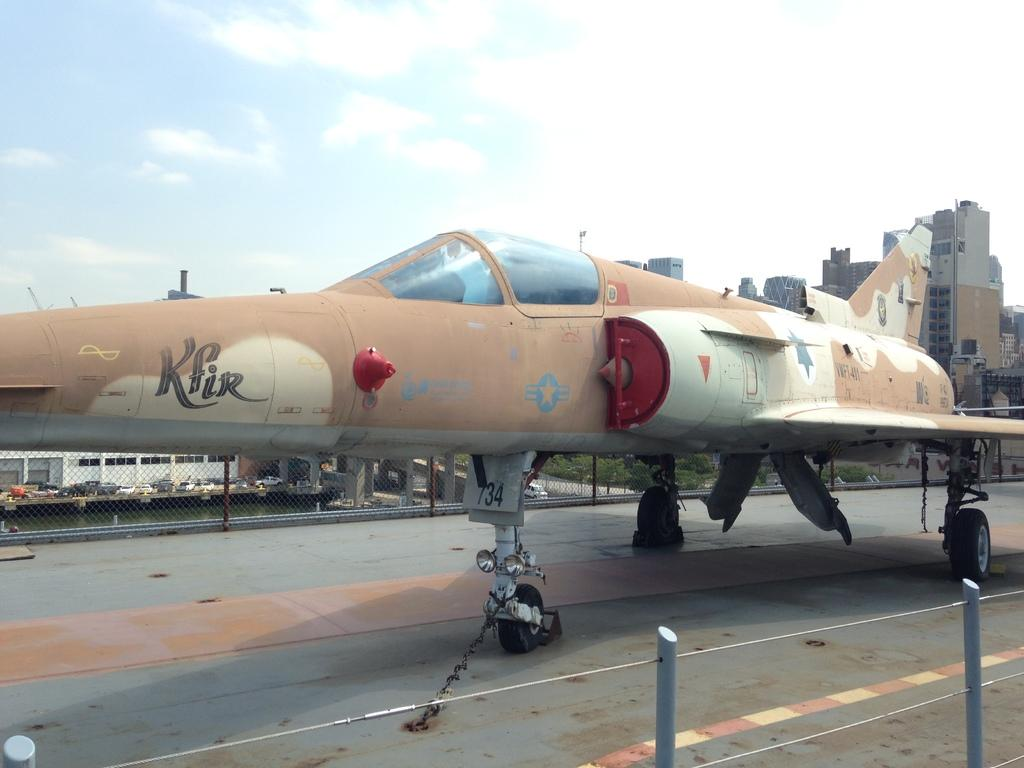<image>
Present a compact description of the photo's key features. a camo Kfir plane is chained to the deck of the area it sits 